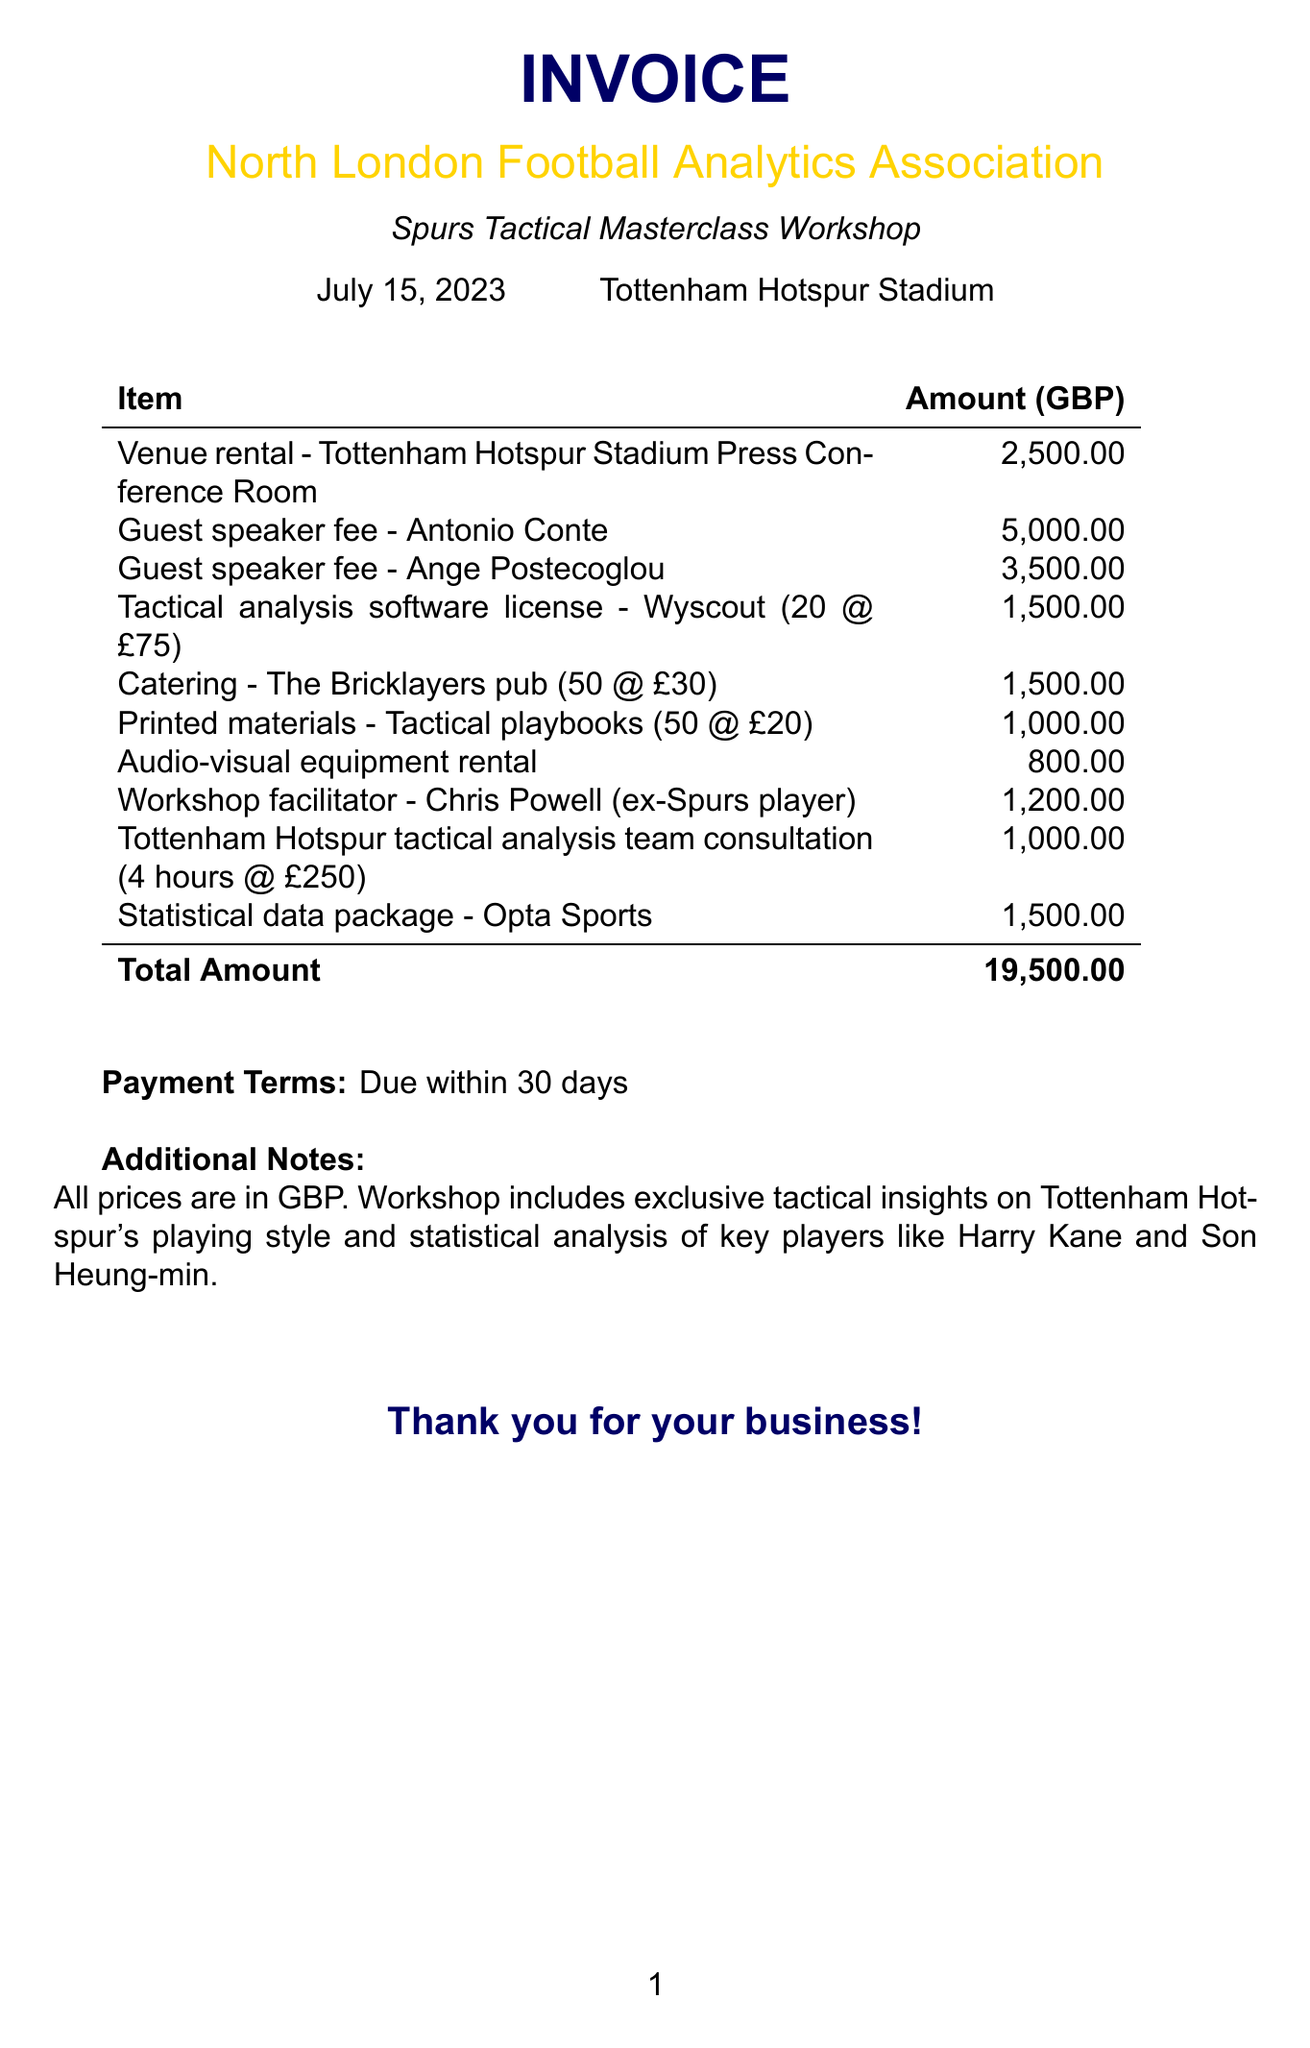what is the event name? The event name is explicitly stated at the beginning of the document under "event_name."
Answer: Spurs Tactical Masterclass Workshop what is the date of the workshop? The date is listed under the event details at the top of the document.
Answer: July 15, 2023 where is the venue located? The location of the venue is mentioned next to the date in the invoice details.
Answer: Tottenham Hotspur Stadium how much is the guest speaker fee for Antonio Conte? The fee for Antonio Conte is itemized in the list of services provided in the document.
Answer: 5000 what is the total amount due? The total amount is clearly stated at the bottom of the itemized list in the document.
Answer: 19500 how many attendees does the catering define? The catering line item specifies the quantity of attendees served.
Answer: 50 who is the workshop facilitator? The document lists Chris Powell as the workshop facilitator.
Answer: Chris Powell how many hours of consultation were provided by the tactical analysis team? The consultation hours are specified in the description for that line item.
Answer: 4 what are the payment terms indicated in the document? The payment terms are explicitly mentioned towards the end of the document.
Answer: Due within 30 days 